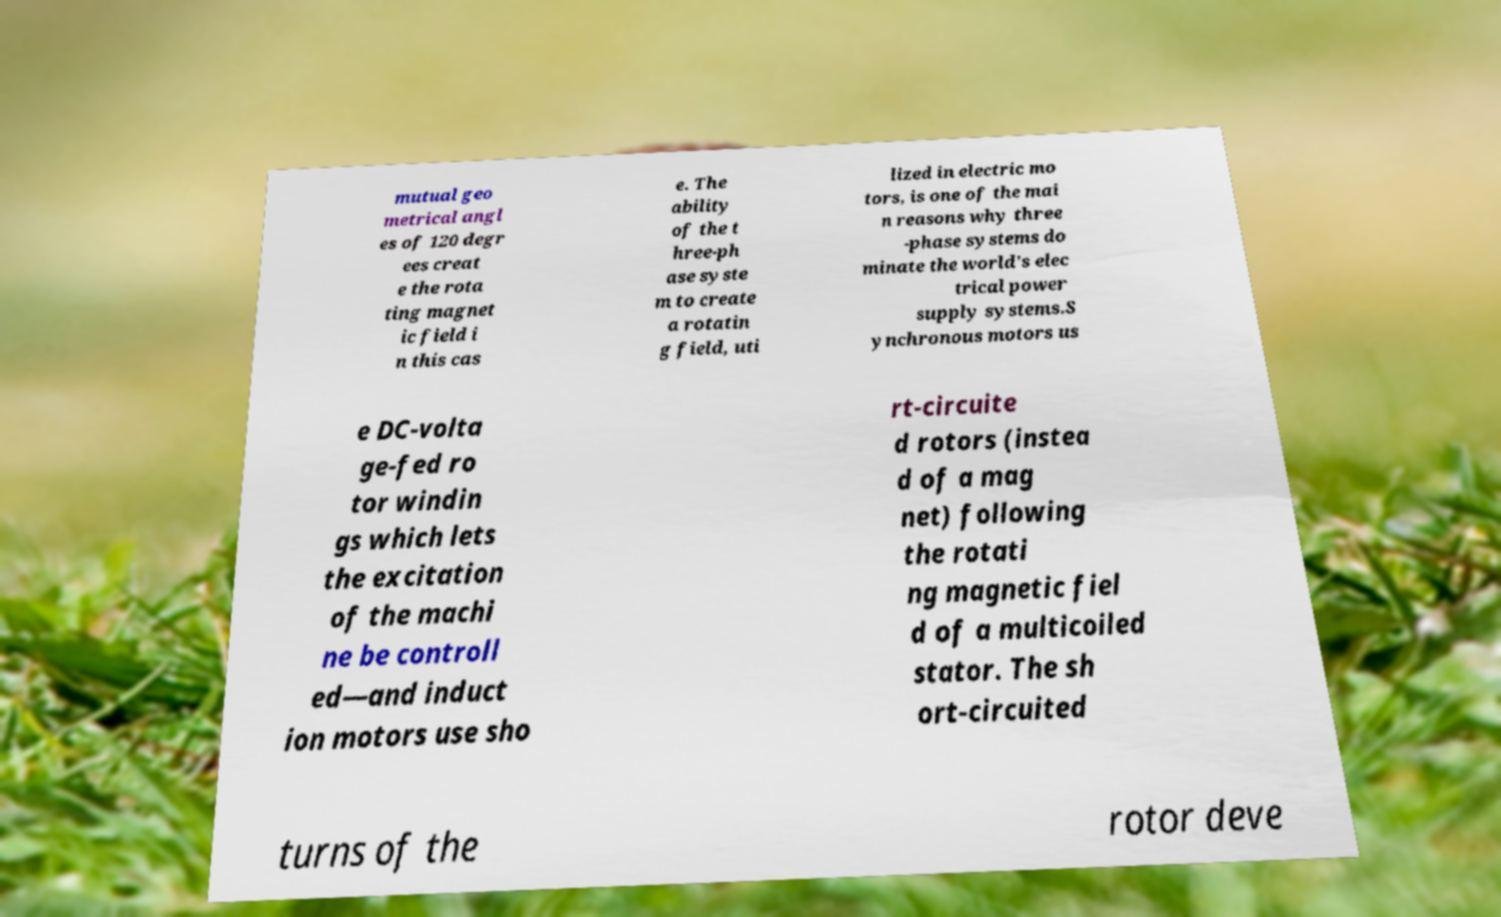For documentation purposes, I need the text within this image transcribed. Could you provide that? mutual geo metrical angl es of 120 degr ees creat e the rota ting magnet ic field i n this cas e. The ability of the t hree-ph ase syste m to create a rotatin g field, uti lized in electric mo tors, is one of the mai n reasons why three -phase systems do minate the world's elec trical power supply systems.S ynchronous motors us e DC-volta ge-fed ro tor windin gs which lets the excitation of the machi ne be controll ed—and induct ion motors use sho rt-circuite d rotors (instea d of a mag net) following the rotati ng magnetic fiel d of a multicoiled stator. The sh ort-circuited turns of the rotor deve 